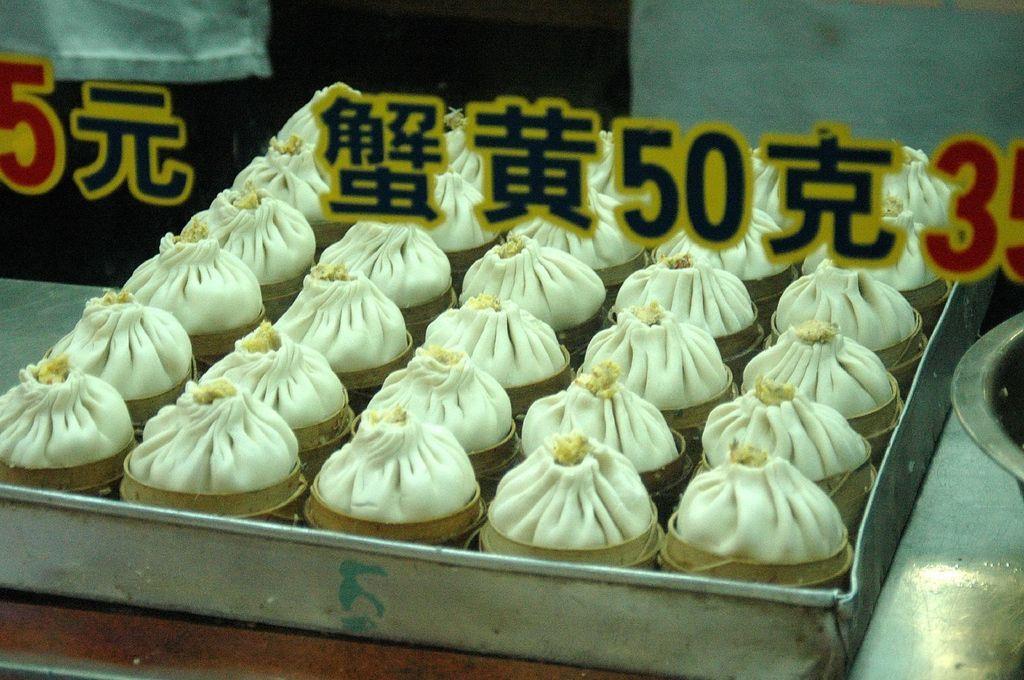Describe this image in one or two sentences. In this image we can see some food items in the tray, which is on the table, also we can see the text on the glass. 